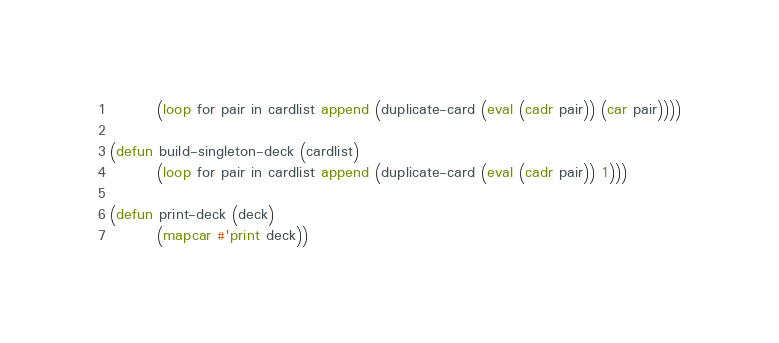Convert code to text. <code><loc_0><loc_0><loc_500><loc_500><_Lisp_>        (loop for pair in cardlist append (duplicate-card (eval (cadr pair)) (car pair))))

(defun build-singleton-deck (cardlist)
        (loop for pair in cardlist append (duplicate-card (eval (cadr pair)) 1)))

(defun print-deck (deck)
        (mapcar #'print deck))

</code> 